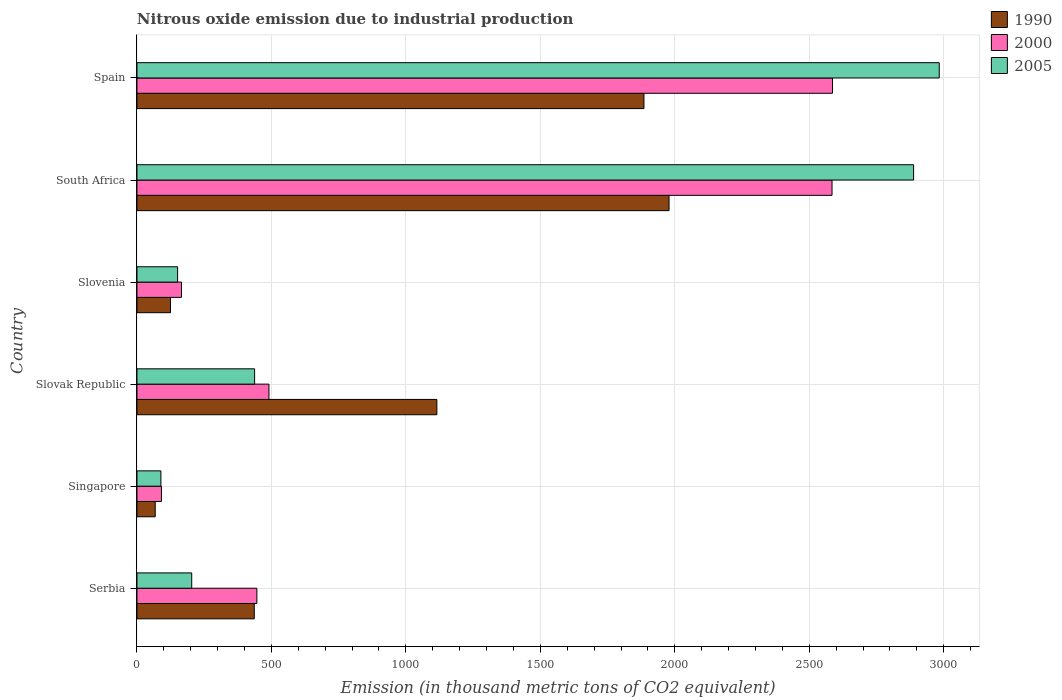How many different coloured bars are there?
Make the answer very short. 3. How many groups of bars are there?
Give a very brief answer. 6. Are the number of bars per tick equal to the number of legend labels?
Offer a terse response. Yes. Are the number of bars on each tick of the Y-axis equal?
Give a very brief answer. Yes. What is the label of the 5th group of bars from the top?
Provide a short and direct response. Singapore. What is the amount of nitrous oxide emitted in 2000 in South Africa?
Provide a succinct answer. 2584.7. Across all countries, what is the maximum amount of nitrous oxide emitted in 1990?
Your response must be concise. 1978.6. Across all countries, what is the minimum amount of nitrous oxide emitted in 1990?
Your answer should be compact. 67.9. In which country was the amount of nitrous oxide emitted in 1990 minimum?
Your answer should be very brief. Singapore. What is the total amount of nitrous oxide emitted in 1990 in the graph?
Your answer should be compact. 5607.9. What is the difference between the amount of nitrous oxide emitted in 1990 in Slovak Republic and that in Slovenia?
Your answer should be compact. 990.5. What is the difference between the amount of nitrous oxide emitted in 2005 in Spain and the amount of nitrous oxide emitted in 1990 in Slovak Republic?
Ensure brevity in your answer.  1868.2. What is the average amount of nitrous oxide emitted in 2000 per country?
Offer a terse response. 1060.75. What is the difference between the amount of nitrous oxide emitted in 2005 and amount of nitrous oxide emitted in 1990 in Spain?
Make the answer very short. 1098.1. What is the ratio of the amount of nitrous oxide emitted in 2000 in Serbia to that in Slovenia?
Offer a terse response. 2.69. Is the amount of nitrous oxide emitted in 2005 in Serbia less than that in Slovenia?
Provide a short and direct response. No. What is the difference between the highest and the second highest amount of nitrous oxide emitted in 1990?
Your answer should be very brief. 93.3. What is the difference between the highest and the lowest amount of nitrous oxide emitted in 1990?
Offer a terse response. 1910.7. Is the sum of the amount of nitrous oxide emitted in 2005 in Serbia and Slovak Republic greater than the maximum amount of nitrous oxide emitted in 1990 across all countries?
Your answer should be compact. No. Is it the case that in every country, the sum of the amount of nitrous oxide emitted in 2000 and amount of nitrous oxide emitted in 1990 is greater than the amount of nitrous oxide emitted in 2005?
Offer a terse response. Yes. Are all the bars in the graph horizontal?
Ensure brevity in your answer.  Yes. How many countries are there in the graph?
Your answer should be compact. 6. What is the difference between two consecutive major ticks on the X-axis?
Your answer should be compact. 500. Are the values on the major ticks of X-axis written in scientific E-notation?
Your response must be concise. No. How many legend labels are there?
Ensure brevity in your answer.  3. How are the legend labels stacked?
Your answer should be very brief. Vertical. What is the title of the graph?
Offer a very short reply. Nitrous oxide emission due to industrial production. Does "1987" appear as one of the legend labels in the graph?
Make the answer very short. No. What is the label or title of the X-axis?
Your answer should be compact. Emission (in thousand metric tons of CO2 equivalent). What is the Emission (in thousand metric tons of CO2 equivalent) of 1990 in Serbia?
Give a very brief answer. 436.2. What is the Emission (in thousand metric tons of CO2 equivalent) of 2000 in Serbia?
Offer a very short reply. 445.9. What is the Emission (in thousand metric tons of CO2 equivalent) of 2005 in Serbia?
Offer a very short reply. 203.6. What is the Emission (in thousand metric tons of CO2 equivalent) in 1990 in Singapore?
Give a very brief answer. 67.9. What is the Emission (in thousand metric tons of CO2 equivalent) of 2000 in Singapore?
Provide a short and direct response. 91.1. What is the Emission (in thousand metric tons of CO2 equivalent) in 2005 in Singapore?
Your response must be concise. 89. What is the Emission (in thousand metric tons of CO2 equivalent) in 1990 in Slovak Republic?
Offer a terse response. 1115.2. What is the Emission (in thousand metric tons of CO2 equivalent) in 2000 in Slovak Republic?
Your response must be concise. 490.8. What is the Emission (in thousand metric tons of CO2 equivalent) in 2005 in Slovak Republic?
Provide a short and direct response. 437.5. What is the Emission (in thousand metric tons of CO2 equivalent) of 1990 in Slovenia?
Provide a short and direct response. 124.7. What is the Emission (in thousand metric tons of CO2 equivalent) in 2000 in Slovenia?
Provide a short and direct response. 165.5. What is the Emission (in thousand metric tons of CO2 equivalent) in 2005 in Slovenia?
Ensure brevity in your answer.  151.1. What is the Emission (in thousand metric tons of CO2 equivalent) in 1990 in South Africa?
Ensure brevity in your answer.  1978.6. What is the Emission (in thousand metric tons of CO2 equivalent) of 2000 in South Africa?
Offer a very short reply. 2584.7. What is the Emission (in thousand metric tons of CO2 equivalent) in 2005 in South Africa?
Give a very brief answer. 2888. What is the Emission (in thousand metric tons of CO2 equivalent) of 1990 in Spain?
Provide a short and direct response. 1885.3. What is the Emission (in thousand metric tons of CO2 equivalent) of 2000 in Spain?
Ensure brevity in your answer.  2586.5. What is the Emission (in thousand metric tons of CO2 equivalent) of 2005 in Spain?
Your answer should be very brief. 2983.4. Across all countries, what is the maximum Emission (in thousand metric tons of CO2 equivalent) of 1990?
Give a very brief answer. 1978.6. Across all countries, what is the maximum Emission (in thousand metric tons of CO2 equivalent) in 2000?
Your answer should be very brief. 2586.5. Across all countries, what is the maximum Emission (in thousand metric tons of CO2 equivalent) of 2005?
Offer a very short reply. 2983.4. Across all countries, what is the minimum Emission (in thousand metric tons of CO2 equivalent) in 1990?
Give a very brief answer. 67.9. Across all countries, what is the minimum Emission (in thousand metric tons of CO2 equivalent) in 2000?
Provide a succinct answer. 91.1. Across all countries, what is the minimum Emission (in thousand metric tons of CO2 equivalent) of 2005?
Ensure brevity in your answer.  89. What is the total Emission (in thousand metric tons of CO2 equivalent) of 1990 in the graph?
Provide a short and direct response. 5607.9. What is the total Emission (in thousand metric tons of CO2 equivalent) of 2000 in the graph?
Your response must be concise. 6364.5. What is the total Emission (in thousand metric tons of CO2 equivalent) in 2005 in the graph?
Your answer should be very brief. 6752.6. What is the difference between the Emission (in thousand metric tons of CO2 equivalent) in 1990 in Serbia and that in Singapore?
Offer a very short reply. 368.3. What is the difference between the Emission (in thousand metric tons of CO2 equivalent) of 2000 in Serbia and that in Singapore?
Your answer should be very brief. 354.8. What is the difference between the Emission (in thousand metric tons of CO2 equivalent) in 2005 in Serbia and that in Singapore?
Your answer should be very brief. 114.6. What is the difference between the Emission (in thousand metric tons of CO2 equivalent) of 1990 in Serbia and that in Slovak Republic?
Your answer should be very brief. -679. What is the difference between the Emission (in thousand metric tons of CO2 equivalent) in 2000 in Serbia and that in Slovak Republic?
Your answer should be compact. -44.9. What is the difference between the Emission (in thousand metric tons of CO2 equivalent) of 2005 in Serbia and that in Slovak Republic?
Make the answer very short. -233.9. What is the difference between the Emission (in thousand metric tons of CO2 equivalent) in 1990 in Serbia and that in Slovenia?
Your response must be concise. 311.5. What is the difference between the Emission (in thousand metric tons of CO2 equivalent) of 2000 in Serbia and that in Slovenia?
Offer a terse response. 280.4. What is the difference between the Emission (in thousand metric tons of CO2 equivalent) of 2005 in Serbia and that in Slovenia?
Offer a terse response. 52.5. What is the difference between the Emission (in thousand metric tons of CO2 equivalent) in 1990 in Serbia and that in South Africa?
Provide a short and direct response. -1542.4. What is the difference between the Emission (in thousand metric tons of CO2 equivalent) of 2000 in Serbia and that in South Africa?
Provide a succinct answer. -2138.8. What is the difference between the Emission (in thousand metric tons of CO2 equivalent) of 2005 in Serbia and that in South Africa?
Offer a terse response. -2684.4. What is the difference between the Emission (in thousand metric tons of CO2 equivalent) in 1990 in Serbia and that in Spain?
Your answer should be compact. -1449.1. What is the difference between the Emission (in thousand metric tons of CO2 equivalent) in 2000 in Serbia and that in Spain?
Make the answer very short. -2140.6. What is the difference between the Emission (in thousand metric tons of CO2 equivalent) of 2005 in Serbia and that in Spain?
Keep it short and to the point. -2779.8. What is the difference between the Emission (in thousand metric tons of CO2 equivalent) in 1990 in Singapore and that in Slovak Republic?
Provide a succinct answer. -1047.3. What is the difference between the Emission (in thousand metric tons of CO2 equivalent) in 2000 in Singapore and that in Slovak Republic?
Make the answer very short. -399.7. What is the difference between the Emission (in thousand metric tons of CO2 equivalent) of 2005 in Singapore and that in Slovak Republic?
Make the answer very short. -348.5. What is the difference between the Emission (in thousand metric tons of CO2 equivalent) in 1990 in Singapore and that in Slovenia?
Offer a terse response. -56.8. What is the difference between the Emission (in thousand metric tons of CO2 equivalent) of 2000 in Singapore and that in Slovenia?
Ensure brevity in your answer.  -74.4. What is the difference between the Emission (in thousand metric tons of CO2 equivalent) of 2005 in Singapore and that in Slovenia?
Your response must be concise. -62.1. What is the difference between the Emission (in thousand metric tons of CO2 equivalent) of 1990 in Singapore and that in South Africa?
Offer a terse response. -1910.7. What is the difference between the Emission (in thousand metric tons of CO2 equivalent) of 2000 in Singapore and that in South Africa?
Provide a short and direct response. -2493.6. What is the difference between the Emission (in thousand metric tons of CO2 equivalent) of 2005 in Singapore and that in South Africa?
Offer a terse response. -2799. What is the difference between the Emission (in thousand metric tons of CO2 equivalent) in 1990 in Singapore and that in Spain?
Give a very brief answer. -1817.4. What is the difference between the Emission (in thousand metric tons of CO2 equivalent) of 2000 in Singapore and that in Spain?
Keep it short and to the point. -2495.4. What is the difference between the Emission (in thousand metric tons of CO2 equivalent) of 2005 in Singapore and that in Spain?
Provide a succinct answer. -2894.4. What is the difference between the Emission (in thousand metric tons of CO2 equivalent) of 1990 in Slovak Republic and that in Slovenia?
Your response must be concise. 990.5. What is the difference between the Emission (in thousand metric tons of CO2 equivalent) of 2000 in Slovak Republic and that in Slovenia?
Keep it short and to the point. 325.3. What is the difference between the Emission (in thousand metric tons of CO2 equivalent) of 2005 in Slovak Republic and that in Slovenia?
Make the answer very short. 286.4. What is the difference between the Emission (in thousand metric tons of CO2 equivalent) in 1990 in Slovak Republic and that in South Africa?
Give a very brief answer. -863.4. What is the difference between the Emission (in thousand metric tons of CO2 equivalent) of 2000 in Slovak Republic and that in South Africa?
Give a very brief answer. -2093.9. What is the difference between the Emission (in thousand metric tons of CO2 equivalent) in 2005 in Slovak Republic and that in South Africa?
Offer a very short reply. -2450.5. What is the difference between the Emission (in thousand metric tons of CO2 equivalent) of 1990 in Slovak Republic and that in Spain?
Keep it short and to the point. -770.1. What is the difference between the Emission (in thousand metric tons of CO2 equivalent) in 2000 in Slovak Republic and that in Spain?
Make the answer very short. -2095.7. What is the difference between the Emission (in thousand metric tons of CO2 equivalent) of 2005 in Slovak Republic and that in Spain?
Your answer should be compact. -2545.9. What is the difference between the Emission (in thousand metric tons of CO2 equivalent) in 1990 in Slovenia and that in South Africa?
Give a very brief answer. -1853.9. What is the difference between the Emission (in thousand metric tons of CO2 equivalent) of 2000 in Slovenia and that in South Africa?
Your answer should be compact. -2419.2. What is the difference between the Emission (in thousand metric tons of CO2 equivalent) of 2005 in Slovenia and that in South Africa?
Provide a short and direct response. -2736.9. What is the difference between the Emission (in thousand metric tons of CO2 equivalent) of 1990 in Slovenia and that in Spain?
Make the answer very short. -1760.6. What is the difference between the Emission (in thousand metric tons of CO2 equivalent) in 2000 in Slovenia and that in Spain?
Provide a short and direct response. -2421. What is the difference between the Emission (in thousand metric tons of CO2 equivalent) of 2005 in Slovenia and that in Spain?
Your answer should be very brief. -2832.3. What is the difference between the Emission (in thousand metric tons of CO2 equivalent) of 1990 in South Africa and that in Spain?
Ensure brevity in your answer.  93.3. What is the difference between the Emission (in thousand metric tons of CO2 equivalent) of 2000 in South Africa and that in Spain?
Give a very brief answer. -1.8. What is the difference between the Emission (in thousand metric tons of CO2 equivalent) of 2005 in South Africa and that in Spain?
Ensure brevity in your answer.  -95.4. What is the difference between the Emission (in thousand metric tons of CO2 equivalent) in 1990 in Serbia and the Emission (in thousand metric tons of CO2 equivalent) in 2000 in Singapore?
Offer a very short reply. 345.1. What is the difference between the Emission (in thousand metric tons of CO2 equivalent) of 1990 in Serbia and the Emission (in thousand metric tons of CO2 equivalent) of 2005 in Singapore?
Your response must be concise. 347.2. What is the difference between the Emission (in thousand metric tons of CO2 equivalent) in 2000 in Serbia and the Emission (in thousand metric tons of CO2 equivalent) in 2005 in Singapore?
Give a very brief answer. 356.9. What is the difference between the Emission (in thousand metric tons of CO2 equivalent) of 1990 in Serbia and the Emission (in thousand metric tons of CO2 equivalent) of 2000 in Slovak Republic?
Make the answer very short. -54.6. What is the difference between the Emission (in thousand metric tons of CO2 equivalent) of 1990 in Serbia and the Emission (in thousand metric tons of CO2 equivalent) of 2005 in Slovak Republic?
Keep it short and to the point. -1.3. What is the difference between the Emission (in thousand metric tons of CO2 equivalent) of 2000 in Serbia and the Emission (in thousand metric tons of CO2 equivalent) of 2005 in Slovak Republic?
Your answer should be compact. 8.4. What is the difference between the Emission (in thousand metric tons of CO2 equivalent) of 1990 in Serbia and the Emission (in thousand metric tons of CO2 equivalent) of 2000 in Slovenia?
Make the answer very short. 270.7. What is the difference between the Emission (in thousand metric tons of CO2 equivalent) of 1990 in Serbia and the Emission (in thousand metric tons of CO2 equivalent) of 2005 in Slovenia?
Provide a short and direct response. 285.1. What is the difference between the Emission (in thousand metric tons of CO2 equivalent) of 2000 in Serbia and the Emission (in thousand metric tons of CO2 equivalent) of 2005 in Slovenia?
Give a very brief answer. 294.8. What is the difference between the Emission (in thousand metric tons of CO2 equivalent) of 1990 in Serbia and the Emission (in thousand metric tons of CO2 equivalent) of 2000 in South Africa?
Offer a terse response. -2148.5. What is the difference between the Emission (in thousand metric tons of CO2 equivalent) in 1990 in Serbia and the Emission (in thousand metric tons of CO2 equivalent) in 2005 in South Africa?
Keep it short and to the point. -2451.8. What is the difference between the Emission (in thousand metric tons of CO2 equivalent) of 2000 in Serbia and the Emission (in thousand metric tons of CO2 equivalent) of 2005 in South Africa?
Give a very brief answer. -2442.1. What is the difference between the Emission (in thousand metric tons of CO2 equivalent) in 1990 in Serbia and the Emission (in thousand metric tons of CO2 equivalent) in 2000 in Spain?
Provide a short and direct response. -2150.3. What is the difference between the Emission (in thousand metric tons of CO2 equivalent) in 1990 in Serbia and the Emission (in thousand metric tons of CO2 equivalent) in 2005 in Spain?
Ensure brevity in your answer.  -2547.2. What is the difference between the Emission (in thousand metric tons of CO2 equivalent) in 2000 in Serbia and the Emission (in thousand metric tons of CO2 equivalent) in 2005 in Spain?
Offer a terse response. -2537.5. What is the difference between the Emission (in thousand metric tons of CO2 equivalent) in 1990 in Singapore and the Emission (in thousand metric tons of CO2 equivalent) in 2000 in Slovak Republic?
Offer a terse response. -422.9. What is the difference between the Emission (in thousand metric tons of CO2 equivalent) of 1990 in Singapore and the Emission (in thousand metric tons of CO2 equivalent) of 2005 in Slovak Republic?
Make the answer very short. -369.6. What is the difference between the Emission (in thousand metric tons of CO2 equivalent) of 2000 in Singapore and the Emission (in thousand metric tons of CO2 equivalent) of 2005 in Slovak Republic?
Keep it short and to the point. -346.4. What is the difference between the Emission (in thousand metric tons of CO2 equivalent) in 1990 in Singapore and the Emission (in thousand metric tons of CO2 equivalent) in 2000 in Slovenia?
Make the answer very short. -97.6. What is the difference between the Emission (in thousand metric tons of CO2 equivalent) of 1990 in Singapore and the Emission (in thousand metric tons of CO2 equivalent) of 2005 in Slovenia?
Make the answer very short. -83.2. What is the difference between the Emission (in thousand metric tons of CO2 equivalent) of 2000 in Singapore and the Emission (in thousand metric tons of CO2 equivalent) of 2005 in Slovenia?
Provide a short and direct response. -60. What is the difference between the Emission (in thousand metric tons of CO2 equivalent) of 1990 in Singapore and the Emission (in thousand metric tons of CO2 equivalent) of 2000 in South Africa?
Provide a short and direct response. -2516.8. What is the difference between the Emission (in thousand metric tons of CO2 equivalent) in 1990 in Singapore and the Emission (in thousand metric tons of CO2 equivalent) in 2005 in South Africa?
Give a very brief answer. -2820.1. What is the difference between the Emission (in thousand metric tons of CO2 equivalent) in 2000 in Singapore and the Emission (in thousand metric tons of CO2 equivalent) in 2005 in South Africa?
Provide a short and direct response. -2796.9. What is the difference between the Emission (in thousand metric tons of CO2 equivalent) of 1990 in Singapore and the Emission (in thousand metric tons of CO2 equivalent) of 2000 in Spain?
Give a very brief answer. -2518.6. What is the difference between the Emission (in thousand metric tons of CO2 equivalent) in 1990 in Singapore and the Emission (in thousand metric tons of CO2 equivalent) in 2005 in Spain?
Ensure brevity in your answer.  -2915.5. What is the difference between the Emission (in thousand metric tons of CO2 equivalent) in 2000 in Singapore and the Emission (in thousand metric tons of CO2 equivalent) in 2005 in Spain?
Make the answer very short. -2892.3. What is the difference between the Emission (in thousand metric tons of CO2 equivalent) of 1990 in Slovak Republic and the Emission (in thousand metric tons of CO2 equivalent) of 2000 in Slovenia?
Offer a terse response. 949.7. What is the difference between the Emission (in thousand metric tons of CO2 equivalent) of 1990 in Slovak Republic and the Emission (in thousand metric tons of CO2 equivalent) of 2005 in Slovenia?
Your answer should be very brief. 964.1. What is the difference between the Emission (in thousand metric tons of CO2 equivalent) of 2000 in Slovak Republic and the Emission (in thousand metric tons of CO2 equivalent) of 2005 in Slovenia?
Provide a short and direct response. 339.7. What is the difference between the Emission (in thousand metric tons of CO2 equivalent) in 1990 in Slovak Republic and the Emission (in thousand metric tons of CO2 equivalent) in 2000 in South Africa?
Your answer should be compact. -1469.5. What is the difference between the Emission (in thousand metric tons of CO2 equivalent) in 1990 in Slovak Republic and the Emission (in thousand metric tons of CO2 equivalent) in 2005 in South Africa?
Your answer should be very brief. -1772.8. What is the difference between the Emission (in thousand metric tons of CO2 equivalent) in 2000 in Slovak Republic and the Emission (in thousand metric tons of CO2 equivalent) in 2005 in South Africa?
Offer a very short reply. -2397.2. What is the difference between the Emission (in thousand metric tons of CO2 equivalent) of 1990 in Slovak Republic and the Emission (in thousand metric tons of CO2 equivalent) of 2000 in Spain?
Offer a terse response. -1471.3. What is the difference between the Emission (in thousand metric tons of CO2 equivalent) of 1990 in Slovak Republic and the Emission (in thousand metric tons of CO2 equivalent) of 2005 in Spain?
Give a very brief answer. -1868.2. What is the difference between the Emission (in thousand metric tons of CO2 equivalent) in 2000 in Slovak Republic and the Emission (in thousand metric tons of CO2 equivalent) in 2005 in Spain?
Give a very brief answer. -2492.6. What is the difference between the Emission (in thousand metric tons of CO2 equivalent) in 1990 in Slovenia and the Emission (in thousand metric tons of CO2 equivalent) in 2000 in South Africa?
Provide a succinct answer. -2460. What is the difference between the Emission (in thousand metric tons of CO2 equivalent) of 1990 in Slovenia and the Emission (in thousand metric tons of CO2 equivalent) of 2005 in South Africa?
Ensure brevity in your answer.  -2763.3. What is the difference between the Emission (in thousand metric tons of CO2 equivalent) of 2000 in Slovenia and the Emission (in thousand metric tons of CO2 equivalent) of 2005 in South Africa?
Your response must be concise. -2722.5. What is the difference between the Emission (in thousand metric tons of CO2 equivalent) of 1990 in Slovenia and the Emission (in thousand metric tons of CO2 equivalent) of 2000 in Spain?
Make the answer very short. -2461.8. What is the difference between the Emission (in thousand metric tons of CO2 equivalent) in 1990 in Slovenia and the Emission (in thousand metric tons of CO2 equivalent) in 2005 in Spain?
Keep it short and to the point. -2858.7. What is the difference between the Emission (in thousand metric tons of CO2 equivalent) in 2000 in Slovenia and the Emission (in thousand metric tons of CO2 equivalent) in 2005 in Spain?
Ensure brevity in your answer.  -2817.9. What is the difference between the Emission (in thousand metric tons of CO2 equivalent) of 1990 in South Africa and the Emission (in thousand metric tons of CO2 equivalent) of 2000 in Spain?
Provide a short and direct response. -607.9. What is the difference between the Emission (in thousand metric tons of CO2 equivalent) in 1990 in South Africa and the Emission (in thousand metric tons of CO2 equivalent) in 2005 in Spain?
Provide a short and direct response. -1004.8. What is the difference between the Emission (in thousand metric tons of CO2 equivalent) in 2000 in South Africa and the Emission (in thousand metric tons of CO2 equivalent) in 2005 in Spain?
Your answer should be compact. -398.7. What is the average Emission (in thousand metric tons of CO2 equivalent) in 1990 per country?
Give a very brief answer. 934.65. What is the average Emission (in thousand metric tons of CO2 equivalent) of 2000 per country?
Give a very brief answer. 1060.75. What is the average Emission (in thousand metric tons of CO2 equivalent) of 2005 per country?
Offer a very short reply. 1125.43. What is the difference between the Emission (in thousand metric tons of CO2 equivalent) of 1990 and Emission (in thousand metric tons of CO2 equivalent) of 2005 in Serbia?
Make the answer very short. 232.6. What is the difference between the Emission (in thousand metric tons of CO2 equivalent) in 2000 and Emission (in thousand metric tons of CO2 equivalent) in 2005 in Serbia?
Your answer should be compact. 242.3. What is the difference between the Emission (in thousand metric tons of CO2 equivalent) of 1990 and Emission (in thousand metric tons of CO2 equivalent) of 2000 in Singapore?
Keep it short and to the point. -23.2. What is the difference between the Emission (in thousand metric tons of CO2 equivalent) of 1990 and Emission (in thousand metric tons of CO2 equivalent) of 2005 in Singapore?
Offer a very short reply. -21.1. What is the difference between the Emission (in thousand metric tons of CO2 equivalent) in 2000 and Emission (in thousand metric tons of CO2 equivalent) in 2005 in Singapore?
Give a very brief answer. 2.1. What is the difference between the Emission (in thousand metric tons of CO2 equivalent) of 1990 and Emission (in thousand metric tons of CO2 equivalent) of 2000 in Slovak Republic?
Ensure brevity in your answer.  624.4. What is the difference between the Emission (in thousand metric tons of CO2 equivalent) of 1990 and Emission (in thousand metric tons of CO2 equivalent) of 2005 in Slovak Republic?
Your answer should be very brief. 677.7. What is the difference between the Emission (in thousand metric tons of CO2 equivalent) of 2000 and Emission (in thousand metric tons of CO2 equivalent) of 2005 in Slovak Republic?
Provide a succinct answer. 53.3. What is the difference between the Emission (in thousand metric tons of CO2 equivalent) of 1990 and Emission (in thousand metric tons of CO2 equivalent) of 2000 in Slovenia?
Your response must be concise. -40.8. What is the difference between the Emission (in thousand metric tons of CO2 equivalent) of 1990 and Emission (in thousand metric tons of CO2 equivalent) of 2005 in Slovenia?
Ensure brevity in your answer.  -26.4. What is the difference between the Emission (in thousand metric tons of CO2 equivalent) in 1990 and Emission (in thousand metric tons of CO2 equivalent) in 2000 in South Africa?
Your response must be concise. -606.1. What is the difference between the Emission (in thousand metric tons of CO2 equivalent) of 1990 and Emission (in thousand metric tons of CO2 equivalent) of 2005 in South Africa?
Ensure brevity in your answer.  -909.4. What is the difference between the Emission (in thousand metric tons of CO2 equivalent) of 2000 and Emission (in thousand metric tons of CO2 equivalent) of 2005 in South Africa?
Your answer should be compact. -303.3. What is the difference between the Emission (in thousand metric tons of CO2 equivalent) in 1990 and Emission (in thousand metric tons of CO2 equivalent) in 2000 in Spain?
Your response must be concise. -701.2. What is the difference between the Emission (in thousand metric tons of CO2 equivalent) of 1990 and Emission (in thousand metric tons of CO2 equivalent) of 2005 in Spain?
Make the answer very short. -1098.1. What is the difference between the Emission (in thousand metric tons of CO2 equivalent) in 2000 and Emission (in thousand metric tons of CO2 equivalent) in 2005 in Spain?
Offer a terse response. -396.9. What is the ratio of the Emission (in thousand metric tons of CO2 equivalent) in 1990 in Serbia to that in Singapore?
Ensure brevity in your answer.  6.42. What is the ratio of the Emission (in thousand metric tons of CO2 equivalent) in 2000 in Serbia to that in Singapore?
Make the answer very short. 4.89. What is the ratio of the Emission (in thousand metric tons of CO2 equivalent) in 2005 in Serbia to that in Singapore?
Give a very brief answer. 2.29. What is the ratio of the Emission (in thousand metric tons of CO2 equivalent) of 1990 in Serbia to that in Slovak Republic?
Your answer should be compact. 0.39. What is the ratio of the Emission (in thousand metric tons of CO2 equivalent) of 2000 in Serbia to that in Slovak Republic?
Your answer should be very brief. 0.91. What is the ratio of the Emission (in thousand metric tons of CO2 equivalent) in 2005 in Serbia to that in Slovak Republic?
Your response must be concise. 0.47. What is the ratio of the Emission (in thousand metric tons of CO2 equivalent) of 1990 in Serbia to that in Slovenia?
Your answer should be compact. 3.5. What is the ratio of the Emission (in thousand metric tons of CO2 equivalent) in 2000 in Serbia to that in Slovenia?
Offer a terse response. 2.69. What is the ratio of the Emission (in thousand metric tons of CO2 equivalent) in 2005 in Serbia to that in Slovenia?
Provide a succinct answer. 1.35. What is the ratio of the Emission (in thousand metric tons of CO2 equivalent) of 1990 in Serbia to that in South Africa?
Provide a short and direct response. 0.22. What is the ratio of the Emission (in thousand metric tons of CO2 equivalent) in 2000 in Serbia to that in South Africa?
Provide a succinct answer. 0.17. What is the ratio of the Emission (in thousand metric tons of CO2 equivalent) in 2005 in Serbia to that in South Africa?
Make the answer very short. 0.07. What is the ratio of the Emission (in thousand metric tons of CO2 equivalent) of 1990 in Serbia to that in Spain?
Provide a succinct answer. 0.23. What is the ratio of the Emission (in thousand metric tons of CO2 equivalent) of 2000 in Serbia to that in Spain?
Offer a very short reply. 0.17. What is the ratio of the Emission (in thousand metric tons of CO2 equivalent) of 2005 in Serbia to that in Spain?
Ensure brevity in your answer.  0.07. What is the ratio of the Emission (in thousand metric tons of CO2 equivalent) of 1990 in Singapore to that in Slovak Republic?
Provide a short and direct response. 0.06. What is the ratio of the Emission (in thousand metric tons of CO2 equivalent) in 2000 in Singapore to that in Slovak Republic?
Provide a succinct answer. 0.19. What is the ratio of the Emission (in thousand metric tons of CO2 equivalent) of 2005 in Singapore to that in Slovak Republic?
Your answer should be compact. 0.2. What is the ratio of the Emission (in thousand metric tons of CO2 equivalent) of 1990 in Singapore to that in Slovenia?
Your response must be concise. 0.54. What is the ratio of the Emission (in thousand metric tons of CO2 equivalent) of 2000 in Singapore to that in Slovenia?
Your answer should be compact. 0.55. What is the ratio of the Emission (in thousand metric tons of CO2 equivalent) in 2005 in Singapore to that in Slovenia?
Offer a very short reply. 0.59. What is the ratio of the Emission (in thousand metric tons of CO2 equivalent) of 1990 in Singapore to that in South Africa?
Give a very brief answer. 0.03. What is the ratio of the Emission (in thousand metric tons of CO2 equivalent) of 2000 in Singapore to that in South Africa?
Give a very brief answer. 0.04. What is the ratio of the Emission (in thousand metric tons of CO2 equivalent) of 2005 in Singapore to that in South Africa?
Your response must be concise. 0.03. What is the ratio of the Emission (in thousand metric tons of CO2 equivalent) of 1990 in Singapore to that in Spain?
Your response must be concise. 0.04. What is the ratio of the Emission (in thousand metric tons of CO2 equivalent) of 2000 in Singapore to that in Spain?
Your answer should be very brief. 0.04. What is the ratio of the Emission (in thousand metric tons of CO2 equivalent) of 2005 in Singapore to that in Spain?
Provide a short and direct response. 0.03. What is the ratio of the Emission (in thousand metric tons of CO2 equivalent) of 1990 in Slovak Republic to that in Slovenia?
Your response must be concise. 8.94. What is the ratio of the Emission (in thousand metric tons of CO2 equivalent) in 2000 in Slovak Republic to that in Slovenia?
Offer a terse response. 2.97. What is the ratio of the Emission (in thousand metric tons of CO2 equivalent) of 2005 in Slovak Republic to that in Slovenia?
Your response must be concise. 2.9. What is the ratio of the Emission (in thousand metric tons of CO2 equivalent) of 1990 in Slovak Republic to that in South Africa?
Provide a short and direct response. 0.56. What is the ratio of the Emission (in thousand metric tons of CO2 equivalent) of 2000 in Slovak Republic to that in South Africa?
Make the answer very short. 0.19. What is the ratio of the Emission (in thousand metric tons of CO2 equivalent) in 2005 in Slovak Republic to that in South Africa?
Keep it short and to the point. 0.15. What is the ratio of the Emission (in thousand metric tons of CO2 equivalent) in 1990 in Slovak Republic to that in Spain?
Provide a succinct answer. 0.59. What is the ratio of the Emission (in thousand metric tons of CO2 equivalent) of 2000 in Slovak Republic to that in Spain?
Make the answer very short. 0.19. What is the ratio of the Emission (in thousand metric tons of CO2 equivalent) of 2005 in Slovak Republic to that in Spain?
Keep it short and to the point. 0.15. What is the ratio of the Emission (in thousand metric tons of CO2 equivalent) of 1990 in Slovenia to that in South Africa?
Your response must be concise. 0.06. What is the ratio of the Emission (in thousand metric tons of CO2 equivalent) of 2000 in Slovenia to that in South Africa?
Offer a terse response. 0.06. What is the ratio of the Emission (in thousand metric tons of CO2 equivalent) in 2005 in Slovenia to that in South Africa?
Offer a terse response. 0.05. What is the ratio of the Emission (in thousand metric tons of CO2 equivalent) in 1990 in Slovenia to that in Spain?
Your answer should be very brief. 0.07. What is the ratio of the Emission (in thousand metric tons of CO2 equivalent) in 2000 in Slovenia to that in Spain?
Your answer should be compact. 0.06. What is the ratio of the Emission (in thousand metric tons of CO2 equivalent) of 2005 in Slovenia to that in Spain?
Offer a very short reply. 0.05. What is the ratio of the Emission (in thousand metric tons of CO2 equivalent) of 1990 in South Africa to that in Spain?
Keep it short and to the point. 1.05. What is the ratio of the Emission (in thousand metric tons of CO2 equivalent) in 2005 in South Africa to that in Spain?
Your answer should be compact. 0.97. What is the difference between the highest and the second highest Emission (in thousand metric tons of CO2 equivalent) of 1990?
Your answer should be very brief. 93.3. What is the difference between the highest and the second highest Emission (in thousand metric tons of CO2 equivalent) in 2000?
Ensure brevity in your answer.  1.8. What is the difference between the highest and the second highest Emission (in thousand metric tons of CO2 equivalent) in 2005?
Offer a terse response. 95.4. What is the difference between the highest and the lowest Emission (in thousand metric tons of CO2 equivalent) in 1990?
Give a very brief answer. 1910.7. What is the difference between the highest and the lowest Emission (in thousand metric tons of CO2 equivalent) in 2000?
Offer a very short reply. 2495.4. What is the difference between the highest and the lowest Emission (in thousand metric tons of CO2 equivalent) in 2005?
Ensure brevity in your answer.  2894.4. 